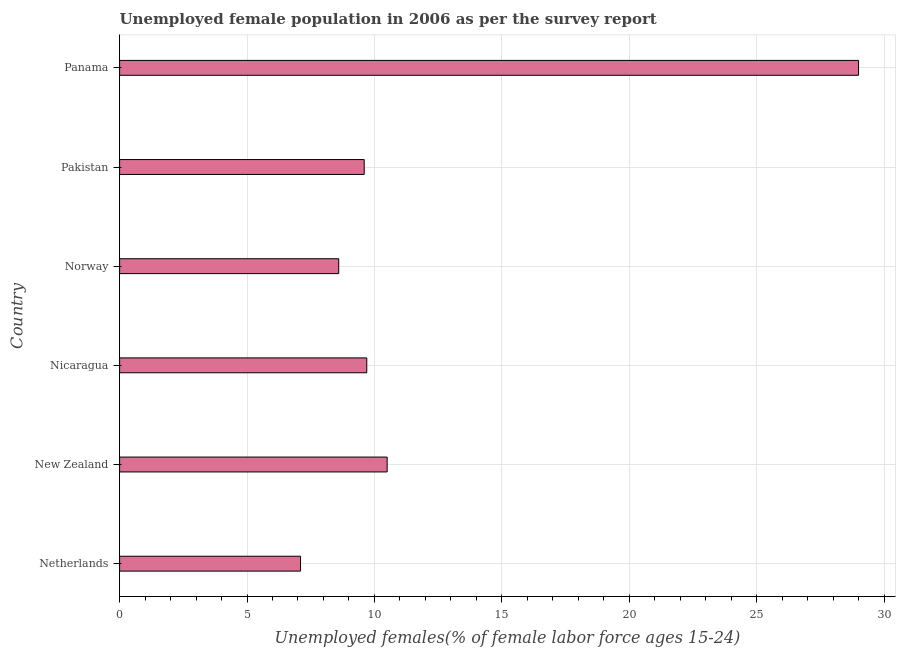Does the graph contain any zero values?
Provide a short and direct response. No. Does the graph contain grids?
Offer a terse response. Yes. What is the title of the graph?
Make the answer very short. Unemployed female population in 2006 as per the survey report. What is the label or title of the X-axis?
Offer a very short reply. Unemployed females(% of female labor force ages 15-24). What is the label or title of the Y-axis?
Give a very brief answer. Country. What is the unemployed female youth in Pakistan?
Give a very brief answer. 9.6. Across all countries, what is the maximum unemployed female youth?
Ensure brevity in your answer.  29. Across all countries, what is the minimum unemployed female youth?
Offer a terse response. 7.1. In which country was the unemployed female youth maximum?
Make the answer very short. Panama. What is the sum of the unemployed female youth?
Give a very brief answer. 74.5. What is the difference between the unemployed female youth in Netherlands and Panama?
Provide a short and direct response. -21.9. What is the average unemployed female youth per country?
Your answer should be very brief. 12.42. What is the median unemployed female youth?
Your answer should be compact. 9.65. What is the ratio of the unemployed female youth in Norway to that in Panama?
Keep it short and to the point. 0.3. Is the unemployed female youth in Netherlands less than that in Norway?
Your answer should be compact. Yes. Is the difference between the unemployed female youth in Netherlands and New Zealand greater than the difference between any two countries?
Your answer should be very brief. No. Is the sum of the unemployed female youth in Netherlands and Norway greater than the maximum unemployed female youth across all countries?
Make the answer very short. No. What is the difference between the highest and the lowest unemployed female youth?
Your answer should be compact. 21.9. How many bars are there?
Your answer should be compact. 6. Are all the bars in the graph horizontal?
Ensure brevity in your answer.  Yes. How many countries are there in the graph?
Provide a succinct answer. 6. Are the values on the major ticks of X-axis written in scientific E-notation?
Offer a very short reply. No. What is the Unemployed females(% of female labor force ages 15-24) of Netherlands?
Make the answer very short. 7.1. What is the Unemployed females(% of female labor force ages 15-24) of Nicaragua?
Provide a short and direct response. 9.7. What is the Unemployed females(% of female labor force ages 15-24) of Norway?
Your response must be concise. 8.6. What is the Unemployed females(% of female labor force ages 15-24) in Pakistan?
Provide a short and direct response. 9.6. What is the Unemployed females(% of female labor force ages 15-24) in Panama?
Keep it short and to the point. 29. What is the difference between the Unemployed females(% of female labor force ages 15-24) in Netherlands and New Zealand?
Your response must be concise. -3.4. What is the difference between the Unemployed females(% of female labor force ages 15-24) in Netherlands and Nicaragua?
Your answer should be very brief. -2.6. What is the difference between the Unemployed females(% of female labor force ages 15-24) in Netherlands and Pakistan?
Your response must be concise. -2.5. What is the difference between the Unemployed females(% of female labor force ages 15-24) in Netherlands and Panama?
Ensure brevity in your answer.  -21.9. What is the difference between the Unemployed females(% of female labor force ages 15-24) in New Zealand and Norway?
Provide a short and direct response. 1.9. What is the difference between the Unemployed females(% of female labor force ages 15-24) in New Zealand and Panama?
Give a very brief answer. -18.5. What is the difference between the Unemployed females(% of female labor force ages 15-24) in Nicaragua and Panama?
Your response must be concise. -19.3. What is the difference between the Unemployed females(% of female labor force ages 15-24) in Norway and Pakistan?
Make the answer very short. -1. What is the difference between the Unemployed females(% of female labor force ages 15-24) in Norway and Panama?
Provide a short and direct response. -20.4. What is the difference between the Unemployed females(% of female labor force ages 15-24) in Pakistan and Panama?
Provide a succinct answer. -19.4. What is the ratio of the Unemployed females(% of female labor force ages 15-24) in Netherlands to that in New Zealand?
Ensure brevity in your answer.  0.68. What is the ratio of the Unemployed females(% of female labor force ages 15-24) in Netherlands to that in Nicaragua?
Your response must be concise. 0.73. What is the ratio of the Unemployed females(% of female labor force ages 15-24) in Netherlands to that in Norway?
Provide a succinct answer. 0.83. What is the ratio of the Unemployed females(% of female labor force ages 15-24) in Netherlands to that in Pakistan?
Provide a succinct answer. 0.74. What is the ratio of the Unemployed females(% of female labor force ages 15-24) in Netherlands to that in Panama?
Your response must be concise. 0.24. What is the ratio of the Unemployed females(% of female labor force ages 15-24) in New Zealand to that in Nicaragua?
Provide a succinct answer. 1.08. What is the ratio of the Unemployed females(% of female labor force ages 15-24) in New Zealand to that in Norway?
Provide a succinct answer. 1.22. What is the ratio of the Unemployed females(% of female labor force ages 15-24) in New Zealand to that in Pakistan?
Give a very brief answer. 1.09. What is the ratio of the Unemployed females(% of female labor force ages 15-24) in New Zealand to that in Panama?
Keep it short and to the point. 0.36. What is the ratio of the Unemployed females(% of female labor force ages 15-24) in Nicaragua to that in Norway?
Ensure brevity in your answer.  1.13. What is the ratio of the Unemployed females(% of female labor force ages 15-24) in Nicaragua to that in Pakistan?
Offer a terse response. 1.01. What is the ratio of the Unemployed females(% of female labor force ages 15-24) in Nicaragua to that in Panama?
Keep it short and to the point. 0.33. What is the ratio of the Unemployed females(% of female labor force ages 15-24) in Norway to that in Pakistan?
Ensure brevity in your answer.  0.9. What is the ratio of the Unemployed females(% of female labor force ages 15-24) in Norway to that in Panama?
Keep it short and to the point. 0.3. What is the ratio of the Unemployed females(% of female labor force ages 15-24) in Pakistan to that in Panama?
Your answer should be very brief. 0.33. 